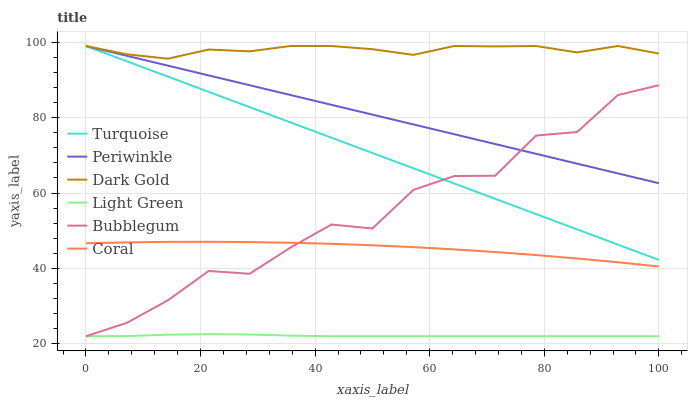Does Light Green have the minimum area under the curve?
Answer yes or no. Yes. Does Dark Gold have the maximum area under the curve?
Answer yes or no. Yes. Does Coral have the minimum area under the curve?
Answer yes or no. No. Does Coral have the maximum area under the curve?
Answer yes or no. No. Is Periwinkle the smoothest?
Answer yes or no. Yes. Is Bubblegum the roughest?
Answer yes or no. Yes. Is Dark Gold the smoothest?
Answer yes or no. No. Is Dark Gold the roughest?
Answer yes or no. No. Does Bubblegum have the lowest value?
Answer yes or no. Yes. Does Coral have the lowest value?
Answer yes or no. No. Does Periwinkle have the highest value?
Answer yes or no. Yes. Does Coral have the highest value?
Answer yes or no. No. Is Coral less than Turquoise?
Answer yes or no. Yes. Is Dark Gold greater than Coral?
Answer yes or no. Yes. Does Turquoise intersect Periwinkle?
Answer yes or no. Yes. Is Turquoise less than Periwinkle?
Answer yes or no. No. Is Turquoise greater than Periwinkle?
Answer yes or no. No. Does Coral intersect Turquoise?
Answer yes or no. No. 